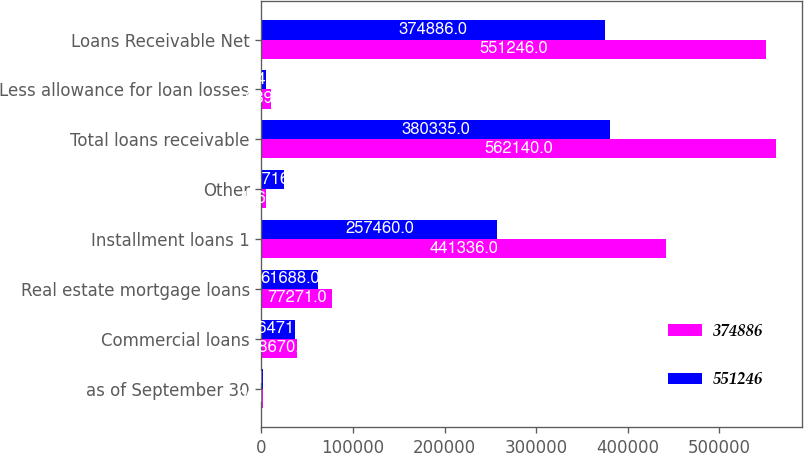Convert chart to OTSL. <chart><loc_0><loc_0><loc_500><loc_500><stacked_bar_chart><ecel><fcel>as of September 30<fcel>Commercial loans<fcel>Real estate mortgage loans<fcel>Installment loans 1<fcel>Other<fcel>Total loans receivable<fcel>Less allowance for loan losses<fcel>Loans Receivable Net<nl><fcel>374886<fcel>2011<fcel>38670<fcel>77271<fcel>441336<fcel>4863<fcel>562140<fcel>10894<fcel>551246<nl><fcel>551246<fcel>2010<fcel>36471<fcel>61688<fcel>257460<fcel>24716<fcel>380335<fcel>5449<fcel>374886<nl></chart> 